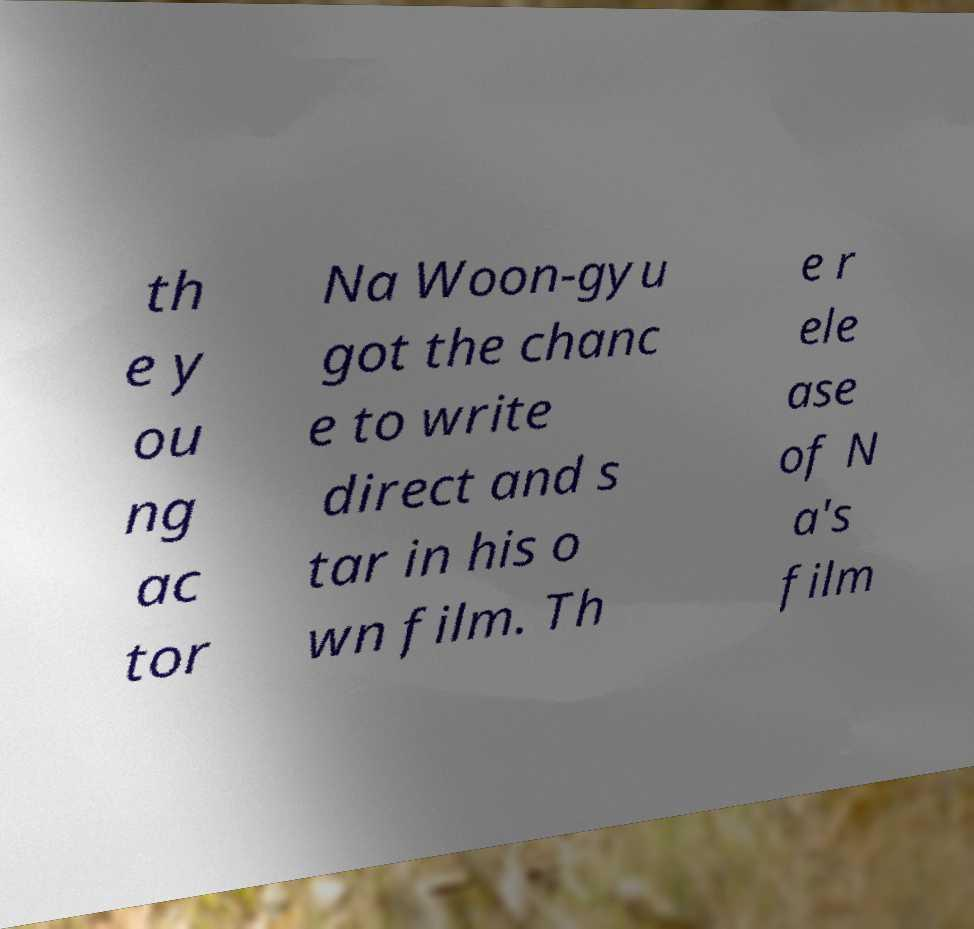Could you extract and type out the text from this image? th e y ou ng ac tor Na Woon-gyu got the chanc e to write direct and s tar in his o wn film. Th e r ele ase of N a's film 